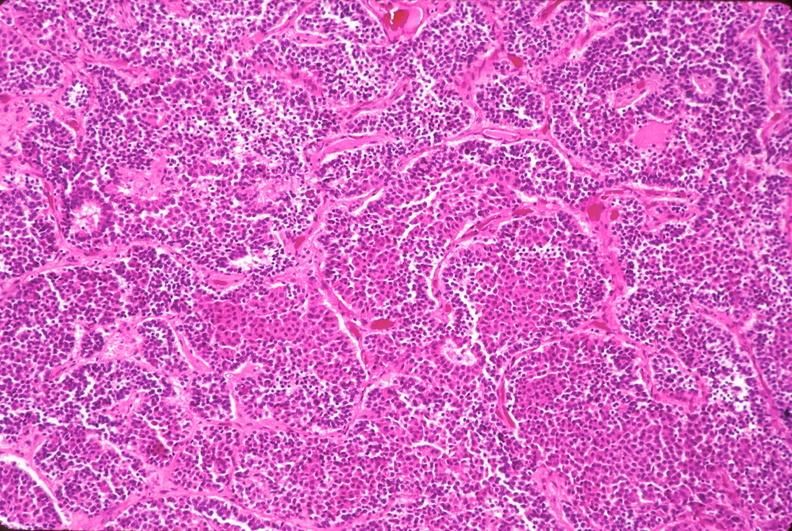what does this image show?
Answer the question using a single word or phrase. Pituitary 